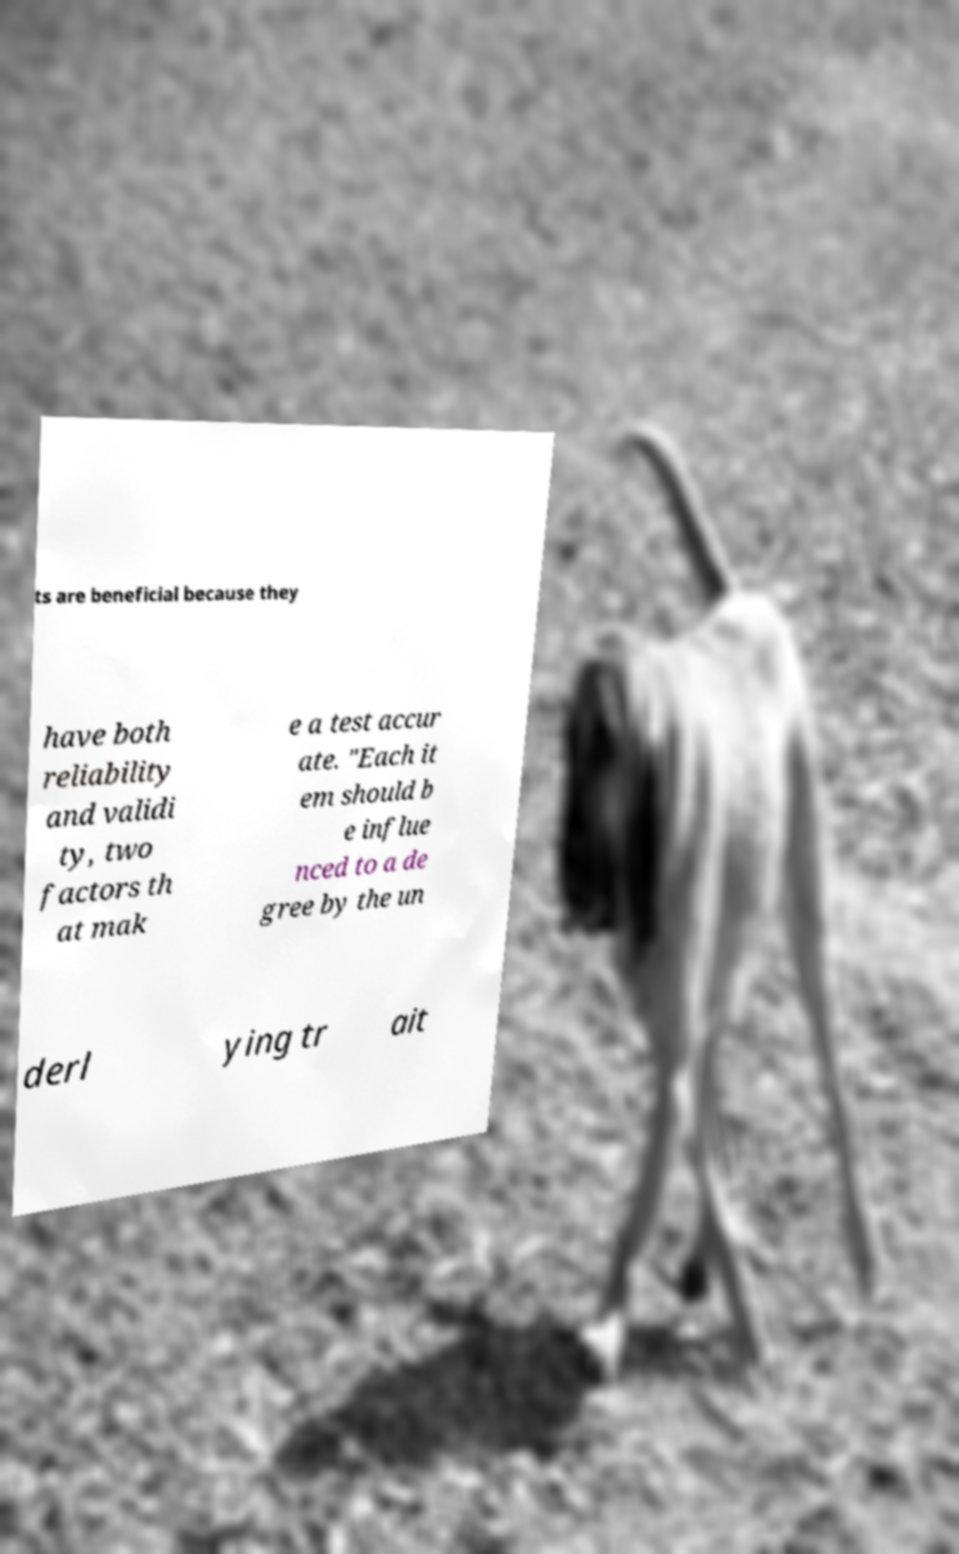Please read and relay the text visible in this image. What does it say? ts are beneficial because they have both reliability and validi ty, two factors th at mak e a test accur ate. "Each it em should b e influe nced to a de gree by the un derl ying tr ait 